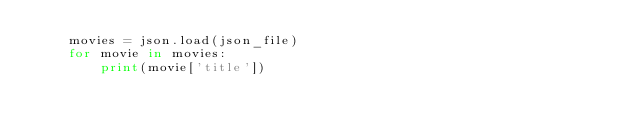Convert code to text. <code><loc_0><loc_0><loc_500><loc_500><_Python_>    movies = json.load(json_file)
    for movie in movies:
        print(movie['title'])
</code> 